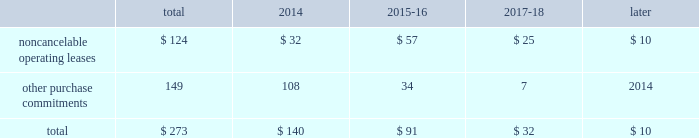23t .
Rowe price group | annual report 2013 contractual obligations the table presents a summary of our future obligations ( in millions ) under the terms of existing operating leases and other contractual cash purchase commitments at december 31 , 2013 .
Other purchase commitments include contractual amounts that will be due for the purchase of goods or services to be used in our operations and may be cancelable at earlier times than those indicated , under certain conditions that may involve termination fees .
Because these obligations are generally of a normal recurring nature , we expect that we will fund them from future cash flows from operations .
The information presented does not include operating expenses or capital expenditures that will be committed in the normal course of operations in 2014 and future years .
The information also excludes the $ 4.8 million of uncertain tax positions discussed in note 8 to our consolidated financial statements because it is not possible to estimate the time period in which a payment might be made to the tax authorities. .
We also have outstanding commitments to fund additional contributions to investment partnerships totaling $ 40.7 million at december 31 , 2013 .
The vast majority of these additional contributions will be made to investment partnerships in which we have an existing investment .
In addition to such amounts , a percentage of prior distributions may be called under certain circumstances .
In january 2014 , we renewed and extended our operating lease at our corporate headquarters in baltimore , maryland through 2027 .
This lease agreement increases the above disclosed total noncancelable operating lease commitments by an additional $ 133.0 million , the vast majority of which will be paid after 2018 .
Critical accounting policies the preparation of financial statements often requires the selection of specific accounting methods and policies from among several acceptable alternatives .
Further , significant estimates and judgments may be required in selecting and applying those methods and policies in the recognition of the assets and liabilities in our consolidated balance sheets , the revenues and expenses in our consolidated statements of income , and the information that is contained in our significant accounting policies and notes to consolidated financial statements .
Making these estimates and judgments requires the analysis of information concerning events that may not yet be complete and of facts and circumstances that may change over time .
Accordingly , actual amounts or future results can differ materially from those estimates that we include currently in our consolidated financial statements , significant accounting policies , and notes .
We present those significant accounting policies used in the preparation of our consolidated financial statements as an integral part of those statements within this 2013 annual report .
In the following discussion , we highlight and explain further certain of those policies that are most critical to the preparation and understanding of our financial statements .
Other-than-temporary impairments of available-for-sale securities .
We generally classify our investment holdings in sponsored funds as available-for-sale if we are not deemed to a have a controlling financial interest .
At the end of each quarter , we mark the carrying amount of each investment holding to fair value and recognize an unrealized gain or loss as a component of comprehensive income within the consolidated statements of comprehensive income .
We next review each individual security position that has an unrealized loss or impairment to determine if that impairment is other than temporary .
In determining whether a mutual fund holding is other-than-temporarily impaired , we consider many factors , including the duration of time it has existed , the severity of the impairment , any subsequent changes in value , and our intent and ability to hold the security for a period of time sufficient for an anticipated recovery in fair value .
Subject to the other considerations noted above , we believe a fund holding with an unrealized loss that has persisted daily throughout the six months between quarter-ends is generally presumed to have an other-than-temporary impairment .
We may also recognize an other-than-temporary loss of less than six months in our consolidated statements of income if the particular circumstances of the underlying investment do not warrant our belief that a near-term recovery is possible. .
What percent of the total future obligations in 2014 are from noncancelable operating leases? 
Computations: (124 / 273)
Answer: 0.45421. 